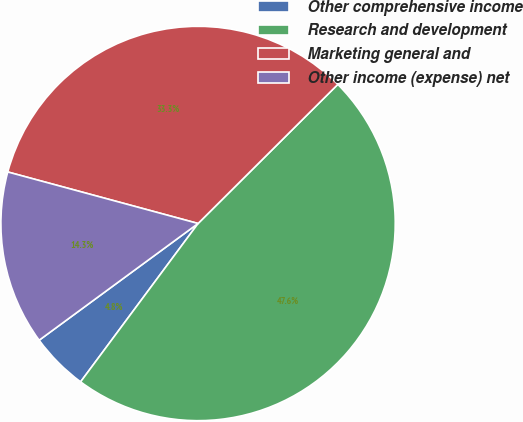Convert chart to OTSL. <chart><loc_0><loc_0><loc_500><loc_500><pie_chart><fcel>Other comprehensive income<fcel>Research and development<fcel>Marketing general and<fcel>Other income (expense) net<nl><fcel>4.76%<fcel>47.62%<fcel>33.33%<fcel>14.29%<nl></chart> 